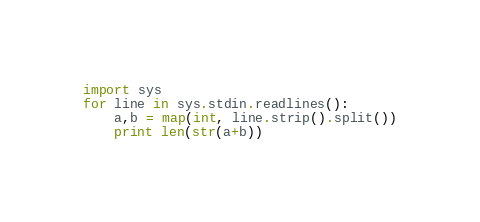<code> <loc_0><loc_0><loc_500><loc_500><_Python_>import sys
for line in sys.stdin.readlines():
    a,b = map(int, line.strip().split())
    print len(str(a+b))</code> 